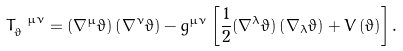<formula> <loc_0><loc_0><loc_500><loc_500>T _ { \vartheta } ^ { \ \mu \nu } = \left ( \nabla ^ { \mu } \vartheta \right ) \left ( \nabla ^ { \nu } \vartheta \right ) - g ^ { \mu \nu } \left [ \frac { 1 } { 2 } ( \nabla ^ { \lambda } \vartheta ) \left ( \nabla _ { \lambda } \vartheta \right ) + V \left ( \vartheta \right ) \right ] .</formula> 